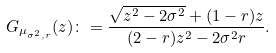<formula> <loc_0><loc_0><loc_500><loc_500>G _ { \mu _ { \sigma ^ { 2 } , r } } ( z ) \colon = \frac { \sqrt { z ^ { 2 } - 2 \sigma ^ { 2 } } + ( 1 - r ) z } { ( 2 - r ) z ^ { 2 } - 2 \sigma ^ { 2 } r } .</formula> 